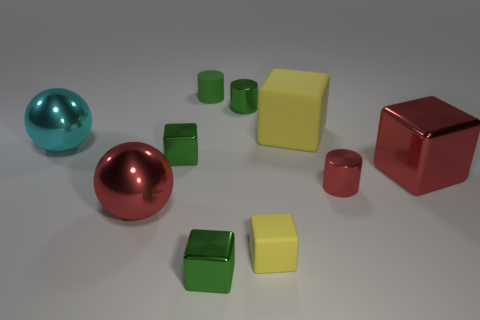There is a small matte cylinder; is it the same color as the tiny shiny cube that is behind the large red metallic ball?
Keep it short and to the point. Yes. Are there any green metal objects of the same shape as the small red object?
Give a very brief answer. Yes. How many objects are either small green matte cylinders or small shiny objects to the right of the green matte thing?
Your answer should be very brief. 4. What number of other things are the same material as the red cube?
Give a very brief answer. 6. How many things are rubber balls or big red shiny things?
Offer a terse response. 2. Are there more large cyan things that are in front of the small green rubber object than yellow matte blocks that are behind the large yellow cube?
Your answer should be compact. Yes. There is a big metal thing that is on the right side of the tiny red shiny cylinder; is it the same color as the tiny metallic cylinder that is in front of the small green shiny cylinder?
Your answer should be compact. Yes. How big is the cylinder that is in front of the green metal object left of the tiny shiny thing that is in front of the big red metal ball?
Your response must be concise. Small. What is the color of the other small metal thing that is the same shape as the small red thing?
Keep it short and to the point. Green. Is the number of cylinders in front of the big cyan thing greater than the number of small red spheres?
Provide a short and direct response. Yes. 